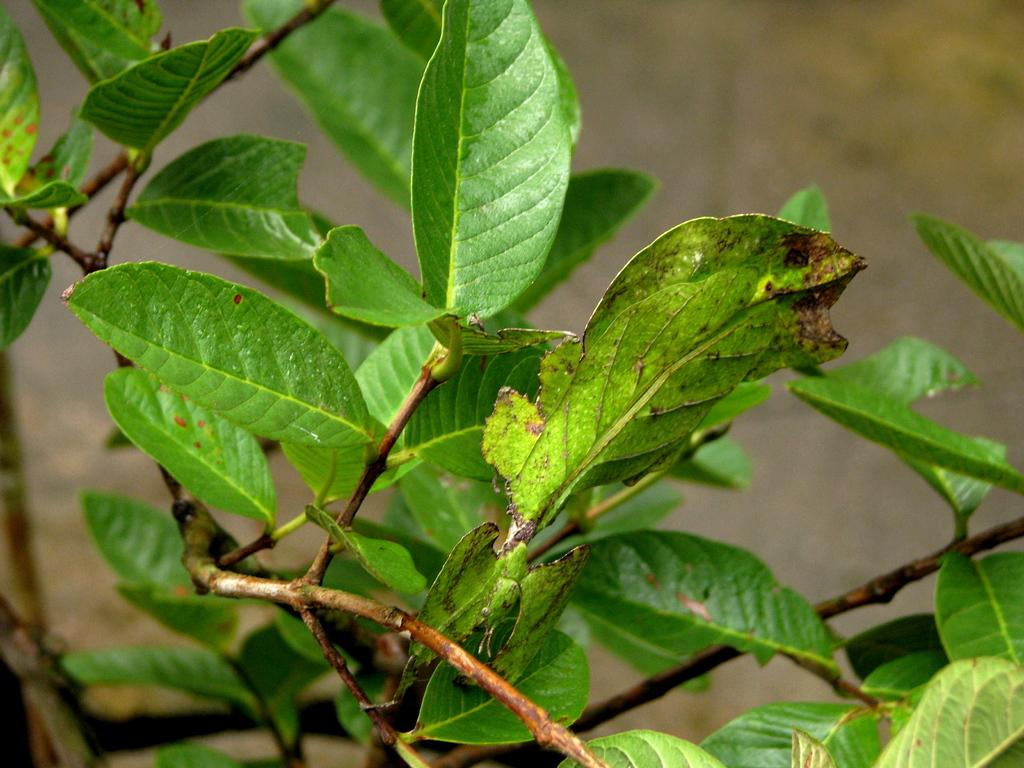What type of vegetation is present in the image? There are green leaves in the image. Can you describe the background of the image? The background of the image is blurred. What type of jewel can be seen sparkling in the image? There is no jewel present in the image; it only features green leaves and a blurred background. 